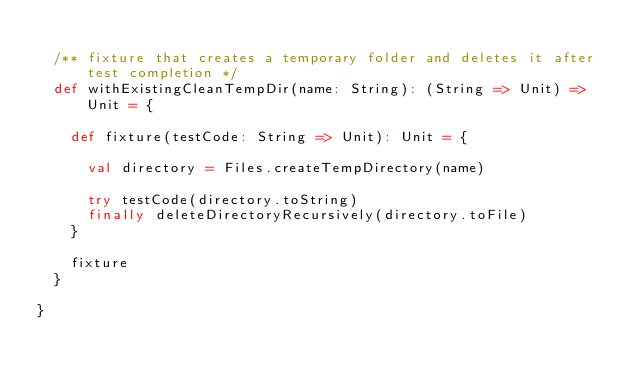Convert code to text. <code><loc_0><loc_0><loc_500><loc_500><_Scala_>
  /** fixture that creates a temporary folder and deletes it after test completion */
  def withExistingCleanTempDir(name: String): (String => Unit) => Unit = {

    def fixture(testCode: String => Unit): Unit = {

      val directory = Files.createTempDirectory(name)

      try testCode(directory.toString)
      finally deleteDirectoryRecursively(directory.toFile)
    }

    fixture
  }

}
</code> 